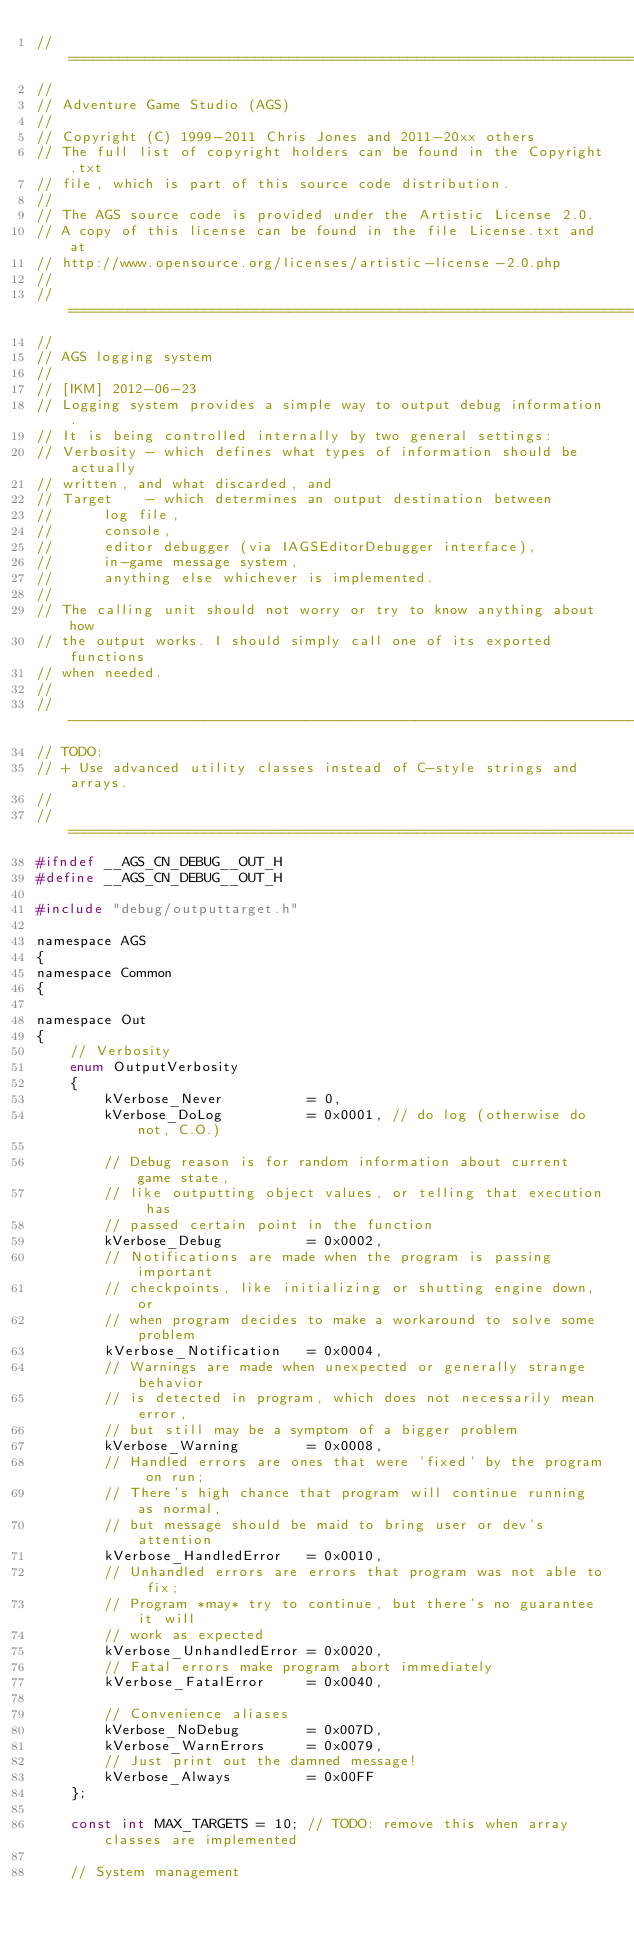Convert code to text. <code><loc_0><loc_0><loc_500><loc_500><_C_>//=============================================================================
//
// Adventure Game Studio (AGS)
//
// Copyright (C) 1999-2011 Chris Jones and 2011-20xx others
// The full list of copyright holders can be found in the Copyright.txt
// file, which is part of this source code distribution.
//
// The AGS source code is provided under the Artistic License 2.0.
// A copy of this license can be found in the file License.txt and at
// http://www.opensource.org/licenses/artistic-license-2.0.php
//
//=============================================================================
//
// AGS logging system
//
// [IKM] 2012-06-23
// Logging system provides a simple way to output debug information.
// It is being controlled internally by two general settings:
// Verbosity - which defines what types of information should be actually
// written, and what discarded, and
// Target    - which determines an output destination between
//      log file,
//      console,
//      editor debugger (via IAGSEditorDebugger interface),
//      in-game message system,
//      anything else whichever is implemented.
//
// The calling unit should not worry or try to know anything about how
// the output works. I should simply call one of its exported functions
// when needed.
//
//-----------------------------------------------------------------------------
// TODO:
// + Use advanced utility classes instead of C-style strings and arrays.    
//
//=============================================================================
#ifndef __AGS_CN_DEBUG__OUT_H
#define __AGS_CN_DEBUG__OUT_H

#include "debug/outputtarget.h"

namespace AGS
{
namespace Common
{

namespace Out
{
    // Verbosity
    enum OutputVerbosity
    {
        kVerbose_Never          = 0,
        kVerbose_DoLog          = 0x0001, // do log (otherwise do not, C.O.)

        // Debug reason is for random information about current game state,
        // like outputting object values, or telling that execution has
        // passed certain point in the function
        kVerbose_Debug          = 0x0002,
        // Notifications are made when the program is passing important
        // checkpoints, like initializing or shutting engine down, or
        // when program decides to make a workaround to solve some problem
        kVerbose_Notification   = 0x0004,
        // Warnings are made when unexpected or generally strange behavior
        // is detected in program, which does not necessarily mean error,
        // but still may be a symptom of a bigger problem
        kVerbose_Warning        = 0x0008,
        // Handled errors are ones that were 'fixed' by the program on run;
        // There's high chance that program will continue running as normal,
        // but message should be maid to bring user or dev's attention
        kVerbose_HandledError   = 0x0010,
        // Unhandled errors are errors that program was not able to fix;
        // Program *may* try to continue, but there's no guarantee it will
        // work as expected
        kVerbose_UnhandledError = 0x0020,
        // Fatal errors make program abort immediately
        kVerbose_FatalError     = 0x0040,

        // Convenience aliases
        kVerbose_NoDebug        = 0x007D,
        kVerbose_WarnErrors     = 0x0079,
        // Just print out the damned message!
        kVerbose_Always         = 0x00FF
    };

    const int MAX_TARGETS = 10; // TODO: remove this when array classes are implemented

    // System management</code> 